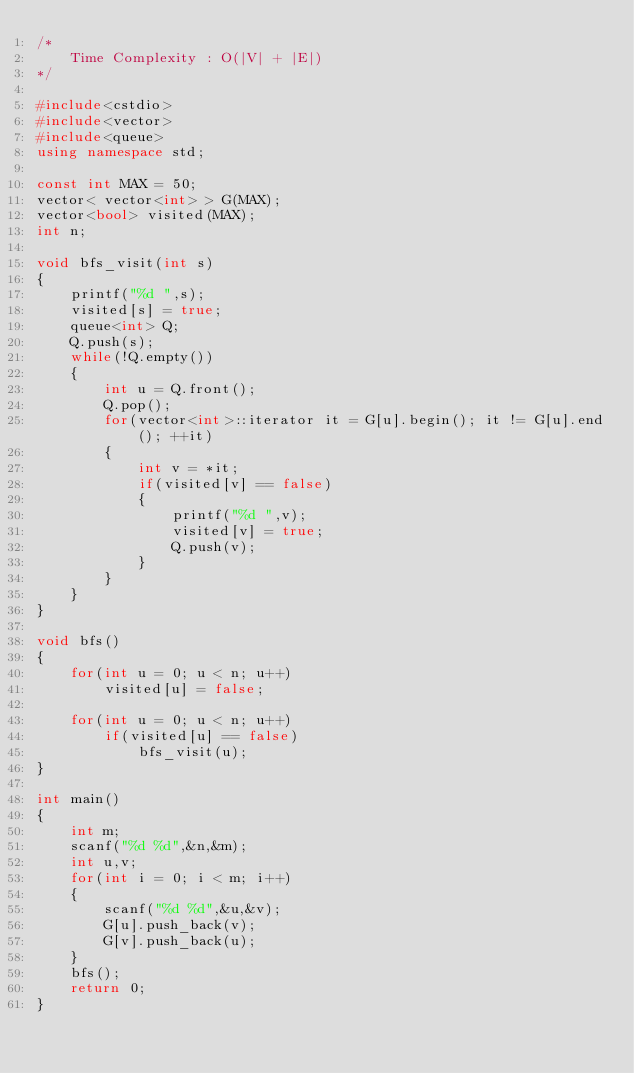Convert code to text. <code><loc_0><loc_0><loc_500><loc_500><_C++_>/*
	Time Complexity : O(|V| + |E|)
*/

#include<cstdio>
#include<vector>
#include<queue>
using namespace std;

const int MAX = 50;
vector< vector<int> > G(MAX);
vector<bool> visited(MAX);
int n;

void bfs_visit(int s)
{
	printf("%d ",s);
	visited[s] = true;	
	queue<int> Q;
	Q.push(s);
	while(!Q.empty())
	{
		int u = Q.front();
		Q.pop();
		for(vector<int>::iterator it = G[u].begin(); it != G[u].end(); ++it)
		{
			int v = *it;
			if(visited[v] == false)
			{
				printf("%d ",v);
				visited[v] = true;
				Q.push(v);
			}
		}
	}
}

void bfs()
{
	for(int u = 0; u < n; u++)
		visited[u] = false;

	for(int u = 0; u < n; u++)
		if(visited[u] == false)
			bfs_visit(u);
}

int main()
{
	int m;
	scanf("%d %d",&n,&m);
	int u,v;
	for(int i = 0; i < m; i++)
	{
		scanf("%d %d",&u,&v);
		G[u].push_back(v);
		G[v].push_back(u);
	}
	bfs();
	return 0;
}
</code> 